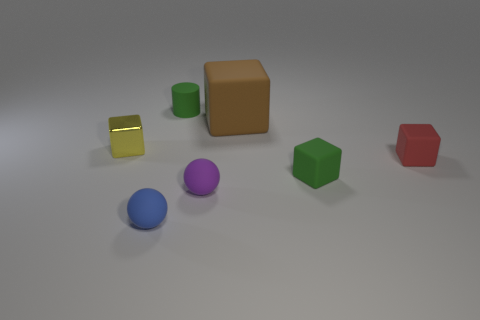There is a tiny matte block that is in front of the red matte object; does it have the same color as the tiny rubber cylinder?
Keep it short and to the point. Yes. Is there anything else that is the same size as the brown block?
Your response must be concise. No. There is another tiny rubber object that is the same shape as the red object; what color is it?
Make the answer very short. Green. How many tiny things are the same color as the cylinder?
Provide a short and direct response. 1. What number of things are either small things that are on the left side of the purple rubber ball or matte blocks?
Ensure brevity in your answer.  6. Are there any purple objects that have the same shape as the small blue thing?
Give a very brief answer. Yes. What is the shape of the small green matte thing that is in front of the thing behind the brown cube?
Give a very brief answer. Cube. What number of cylinders are either tiny blue rubber objects or tiny purple rubber things?
Keep it short and to the point. 0. Does the small green rubber thing that is on the right side of the rubber cylinder have the same shape as the red matte object that is on the right side of the tiny metal thing?
Provide a succinct answer. Yes. What color is the block that is to the right of the tiny blue matte thing and behind the small red object?
Keep it short and to the point. Brown. 